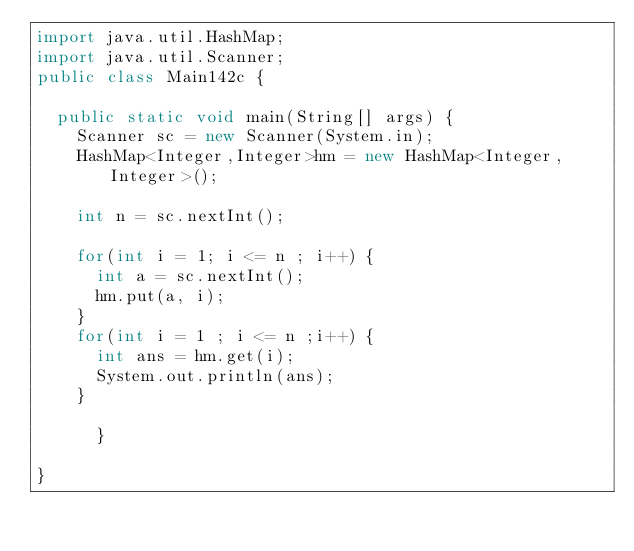Convert code to text. <code><loc_0><loc_0><loc_500><loc_500><_Java_>import java.util.HashMap;
import java.util.Scanner;
public class Main142c {

	public static void main(String[] args) {
		Scanner sc = new Scanner(System.in);
		HashMap<Integer,Integer>hm = new HashMap<Integer,Integer>();

		int n = sc.nextInt();
		
		for(int i = 1; i <= n ; i++) {
			int a = sc.nextInt();
			hm.put(a, i);
		}
		for(int i = 1 ; i <= n ;i++) {
			int ans = hm.get(i);
			System.out.println(ans);
		}
		
			}

}
</code> 